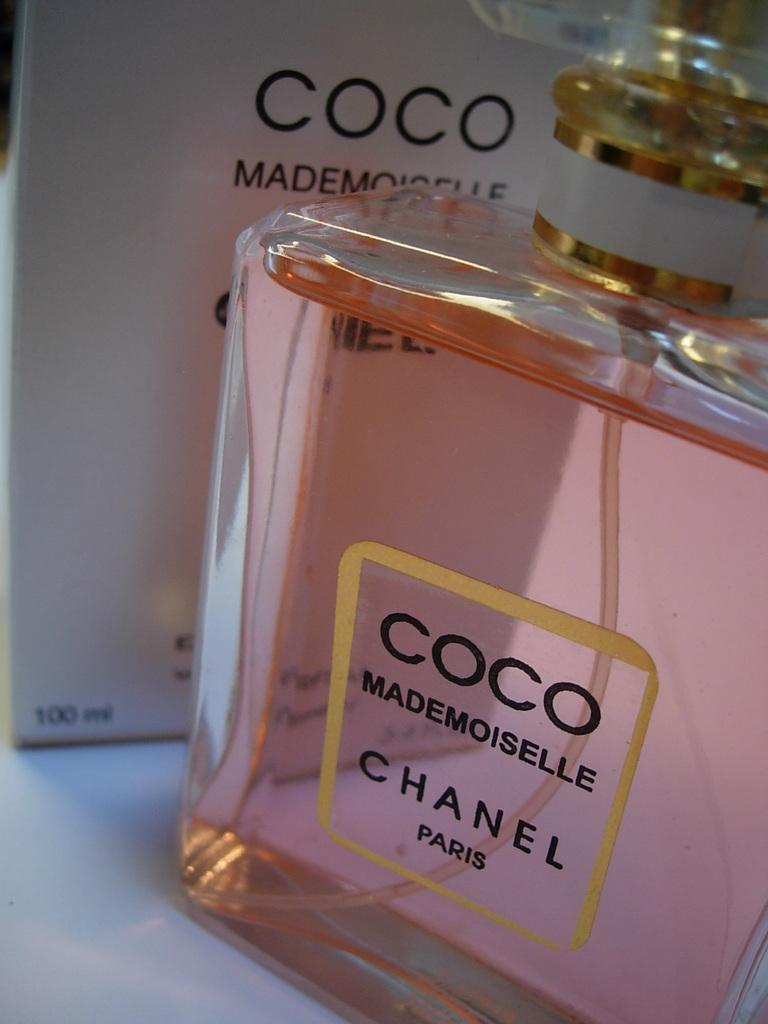Provide a one-sentence caption for the provided image. A bottle of perfume the brand is Chanel. 